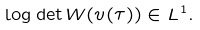Convert formula to latex. <formula><loc_0><loc_0><loc_500><loc_500>\log \det W ( v ( \tau ) ) \in L ^ { 1 } .</formula> 